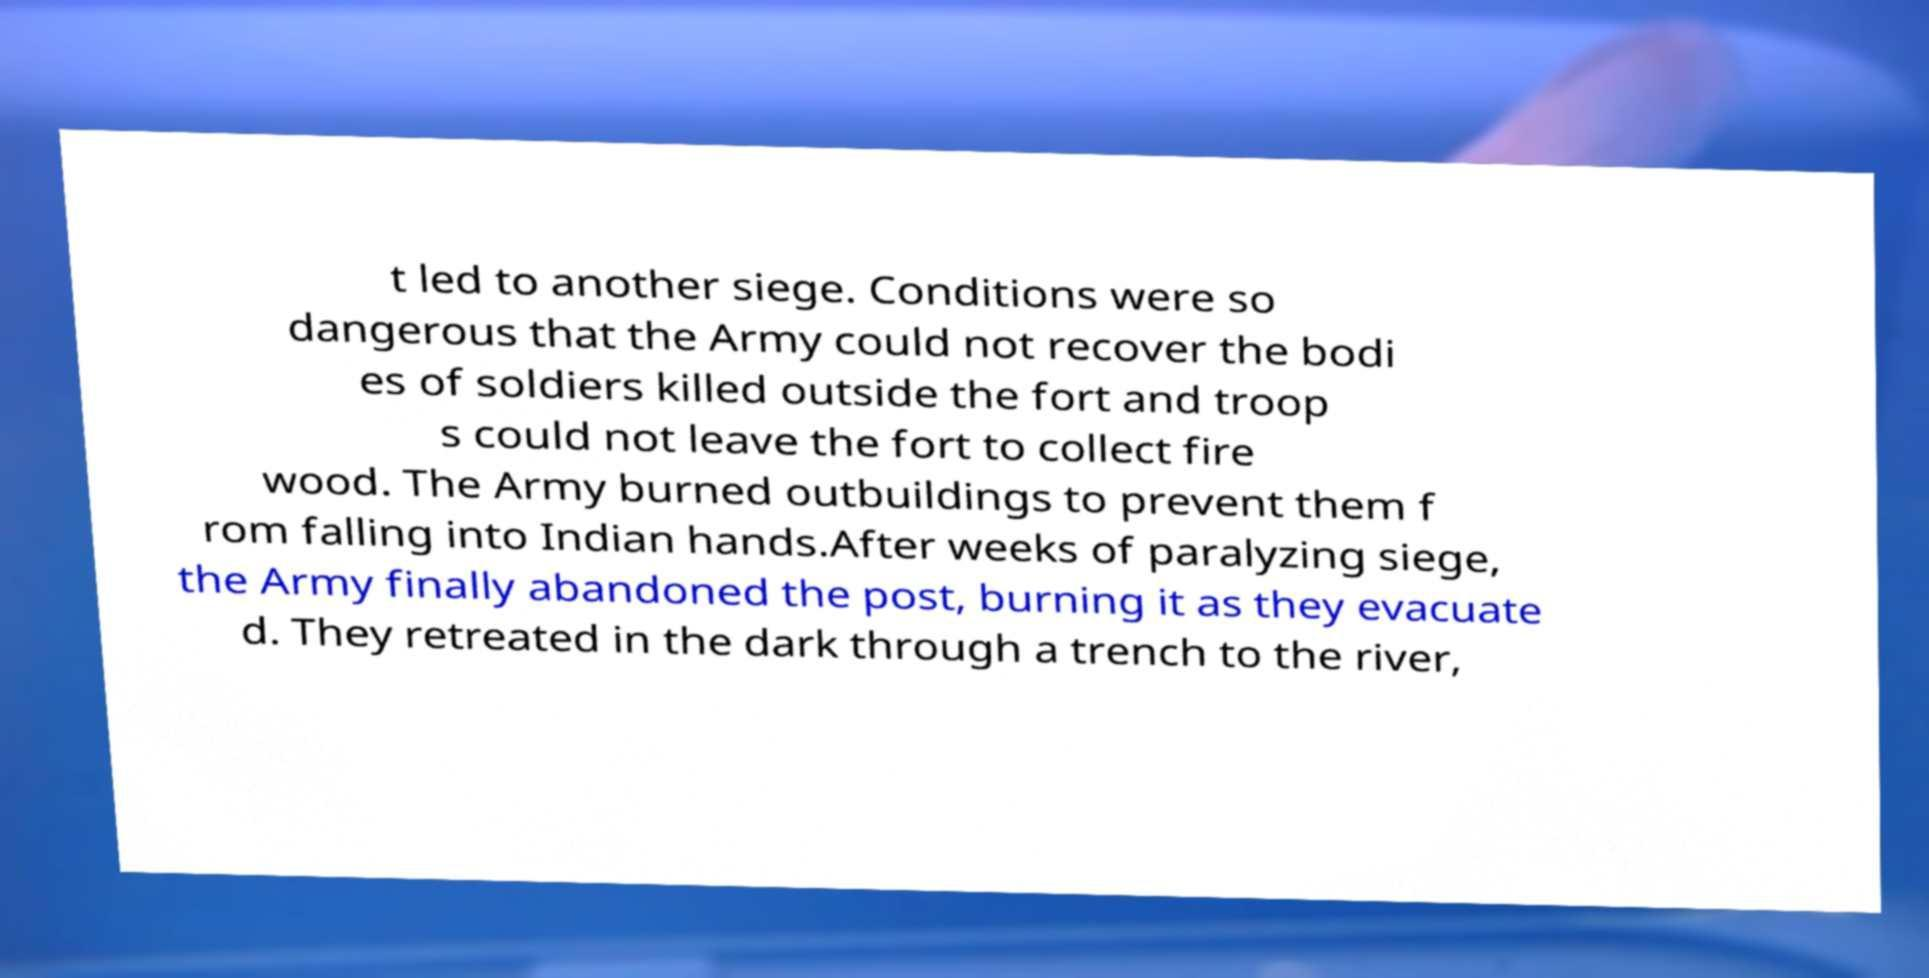Can you read and provide the text displayed in the image?This photo seems to have some interesting text. Can you extract and type it out for me? t led to another siege. Conditions were so dangerous that the Army could not recover the bodi es of soldiers killed outside the fort and troop s could not leave the fort to collect fire wood. The Army burned outbuildings to prevent them f rom falling into Indian hands.After weeks of paralyzing siege, the Army finally abandoned the post, burning it as they evacuate d. They retreated in the dark through a trench to the river, 